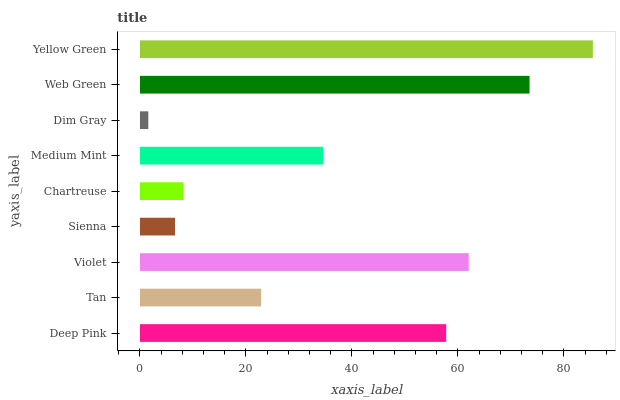Is Dim Gray the minimum?
Answer yes or no. Yes. Is Yellow Green the maximum?
Answer yes or no. Yes. Is Tan the minimum?
Answer yes or no. No. Is Tan the maximum?
Answer yes or no. No. Is Deep Pink greater than Tan?
Answer yes or no. Yes. Is Tan less than Deep Pink?
Answer yes or no. Yes. Is Tan greater than Deep Pink?
Answer yes or no. No. Is Deep Pink less than Tan?
Answer yes or no. No. Is Medium Mint the high median?
Answer yes or no. Yes. Is Medium Mint the low median?
Answer yes or no. Yes. Is Web Green the high median?
Answer yes or no. No. Is Deep Pink the low median?
Answer yes or no. No. 